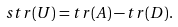<formula> <loc_0><loc_0><loc_500><loc_500>s t r ( U ) = t r ( A ) - t r ( D ) .</formula> 